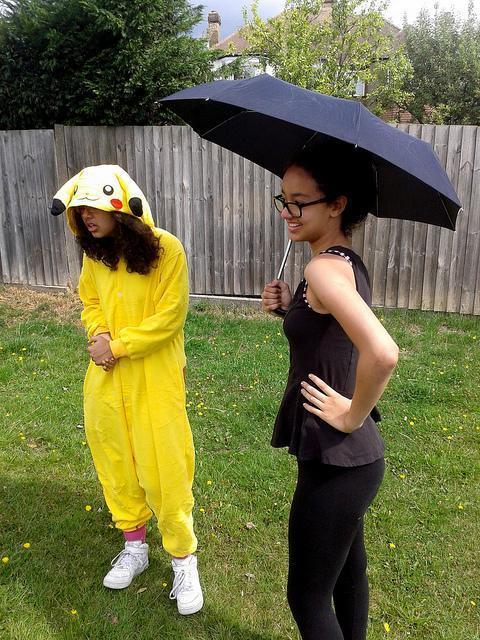How many people are there?
Give a very brief answer. 2. 